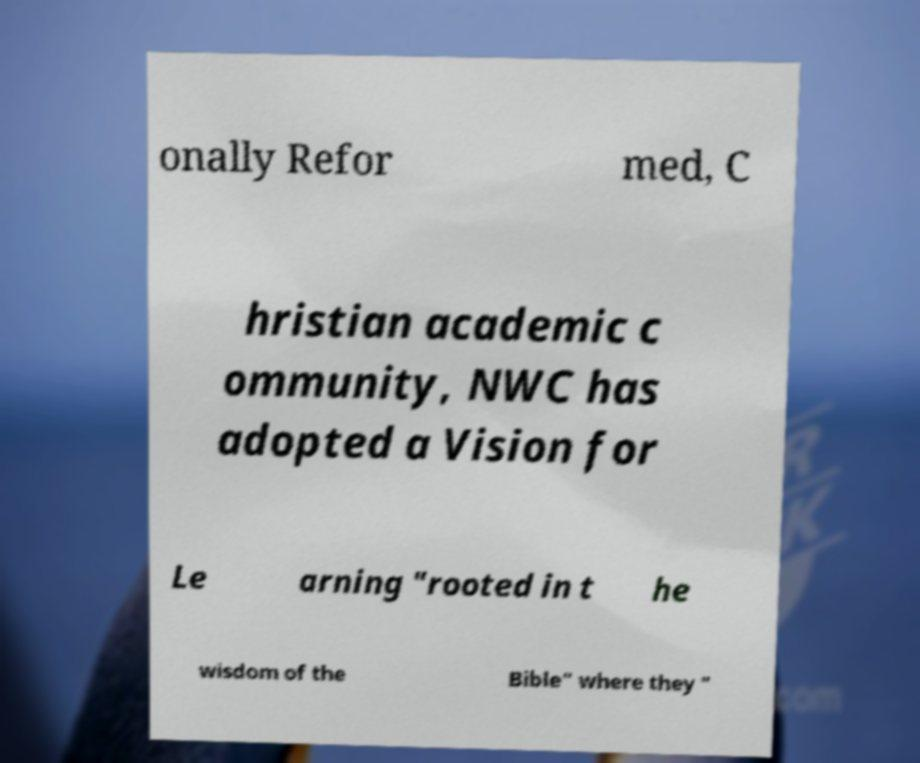For documentation purposes, I need the text within this image transcribed. Could you provide that? onally Refor med, C hristian academic c ommunity, NWC has adopted a Vision for Le arning "rooted in t he wisdom of the Bible" where they " 